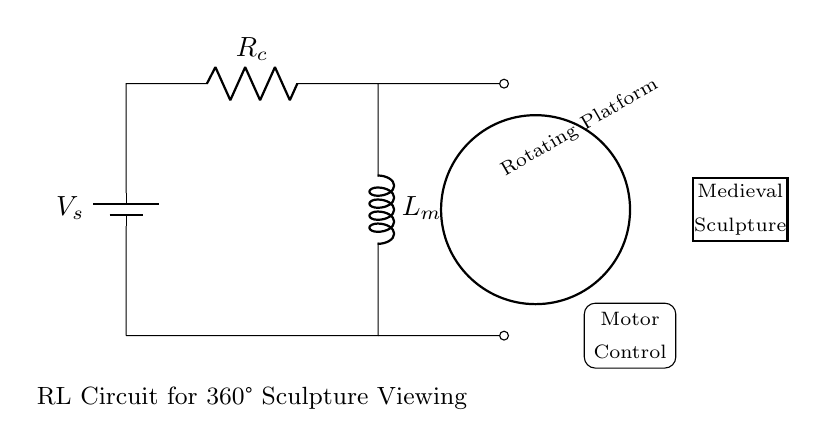What is the type of battery used in this circuit? The circuit diagram shows a symbol for a battery labeled as V_s. This indicates the presence of a voltage source that powers the circuit. The specific designation V_s implies it's a signal voltage source.
Answer: battery What component is used for resistance in the circuit? The circuit diagram features a resistor symbol labeled as R_c. This indicates its role in limiting current and creating a voltage drop within the circuit.
Answer: R_c What is the purpose of the inductor in this RL circuit? In this circuit, the inductor labeled as L_m plays a crucial role in storing energy in the form of a magnetic field when current flows through it. It helps control the current change to the motor, providing a smooth operation.
Answer: storing energy How are the motor and rotating platform connected in this circuit? The circuit connects a motor control mechanism to the rotating platform, which is represented by a thick arrow indicating motion. The output from the circuit controls the motor that powers the rotation of the sculpture.
Answer: direct connection What is the flow direction of the current in this RL circuit? The current flows from the battery represented by V_s through the resistor R_c and the inductor L_m, completing the loop. The indicated flow path demonstrates how current moves to power the motor.
Answer: clockwise What is the effect of increasing resistance on the current flow in this circuit? Increasing resistance (R_c) in the RL circuit results in a decrease in the overall current flowing through the circuit as per Ohm's law (V = IR). This relationship influences the performance of the motor by reducing the current available to it, impacting the rotation speed of the platform.
Answer: decreases current What role does the inductance play in the delay of current in this circuit? In this RL circuit, the inductor (L_m) introduces a delay in the rise of current due to its property of opposing changes in current. When voltage is applied, the inductor resists the initial current flow, resulting in a time constant defined by L/R, which determines how quickly the current reaches its maximum value.
Answer: delays current rise 